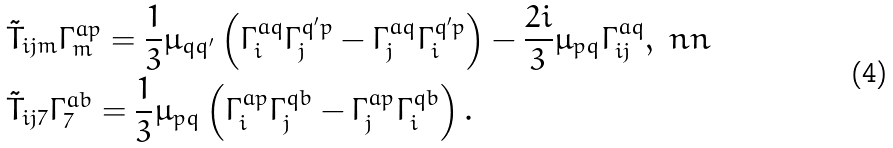Convert formula to latex. <formula><loc_0><loc_0><loc_500><loc_500>& \tilde { T } _ { i j m } \Gamma _ { m } ^ { a p } = \frac { 1 } 3 \mu _ { q q ^ { \prime } } \left ( \Gamma _ { i } ^ { a q } \Gamma _ { j } ^ { q ^ { \prime } p } - \Gamma _ { j } ^ { a q } \Gamma _ { i } ^ { q ^ { \prime } p } \right ) - \frac { 2 i } 3 \mu _ { p q } \Gamma _ { i j } ^ { a q } , \ n n \\ & \tilde { T } _ { i j 7 } \Gamma _ { 7 } ^ { a b } = \frac { 1 } 3 \mu _ { p q } \left ( \Gamma _ { i } ^ { a p } \Gamma _ { j } ^ { q b } - \Gamma _ { j } ^ { a p } \Gamma _ { i } ^ { q b } \right ) .</formula> 